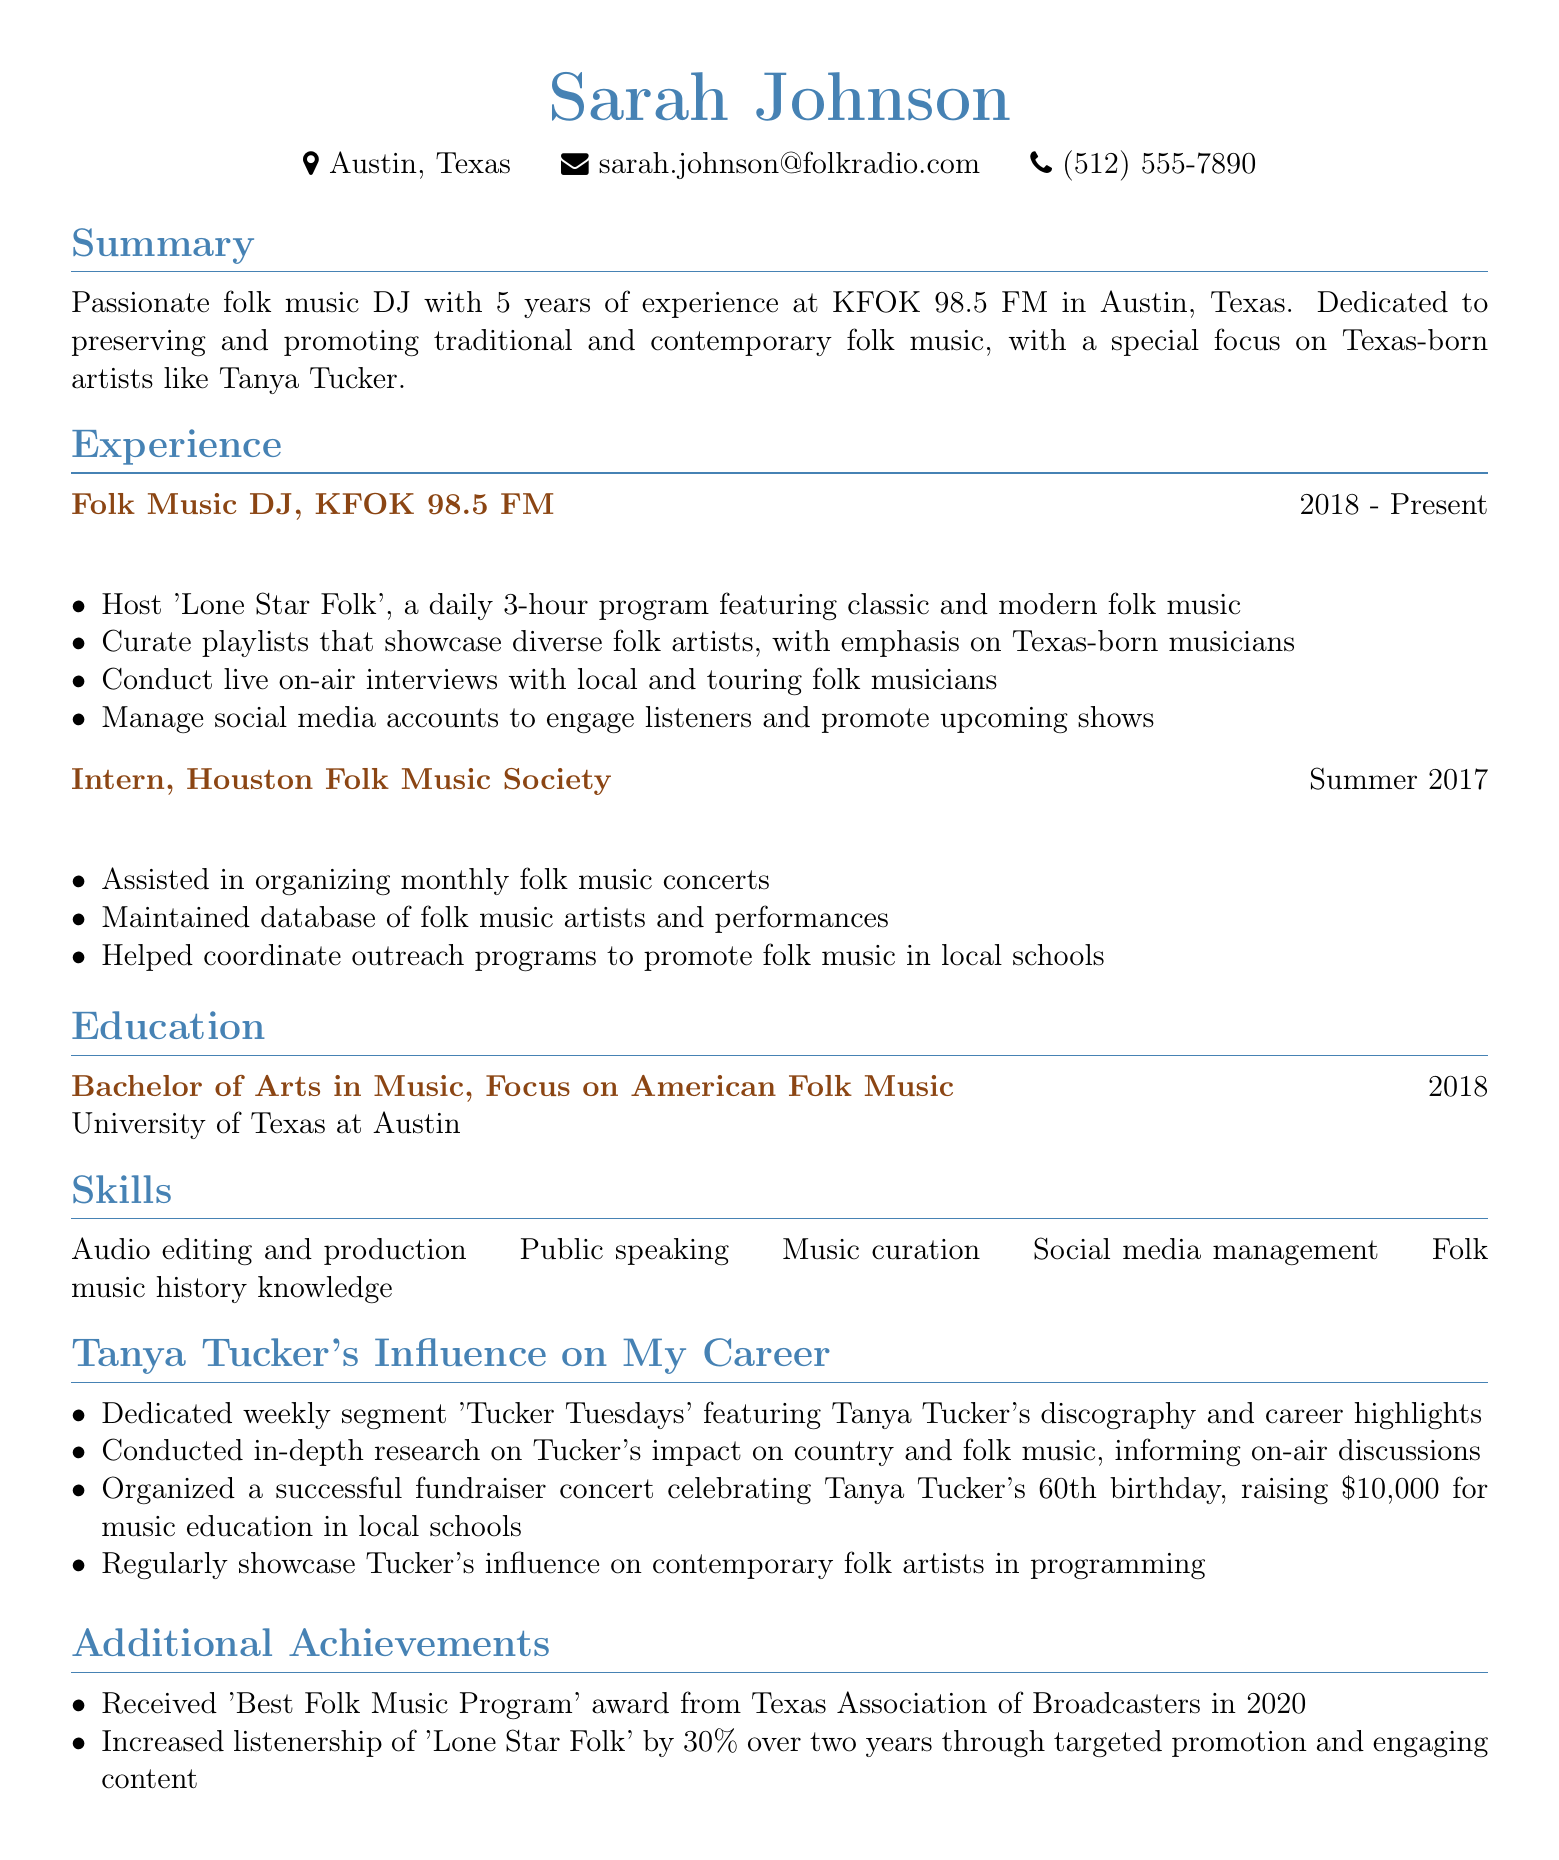What is the name of the DJ? Sarah Johnson is the name listed at the top of the document as the DJ.
Answer: Sarah Johnson Where does Sarah work? The document states that Sarah works at KFOK 98.5 FM in Austin, Texas.
Answer: KFOK 98.5 FM What year did Sarah start working as a DJ? The experience section indicates she has been a DJ since 2018.
Answer: 2018 What is the title of Sarah's weekly segment dedicated to Tanya Tucker? The document specifies that the segment is titled 'Tucker Tuesdays'.
Answer: Tucker Tuesdays How much money was raised during the fundraiser concert for Tanya Tucker's 60th birthday? The document mentions that $10,000 was raised for music education.
Answer: $10,000 What award did Sarah's program receive in 2020? The additional achievements section refers to a "Best Folk Music Program" award from Texas Association of Broadcasters.
Answer: Best Folk Music Program How long did Sarah intern at the Houston Folk Music Society? The document notes that she interned during the summer of 2017, which typically suggests a time frame of about three months.
Answer: Summer 2017 What was Sarah’s major in college? The education section reveals that she focused on American Folk Music.
Answer: Focus on American Folk Music What was the percentage increase in listenership for 'Lone Star Folk'? The résumé states that listenership increased by 30% over two years.
Answer: 30% 